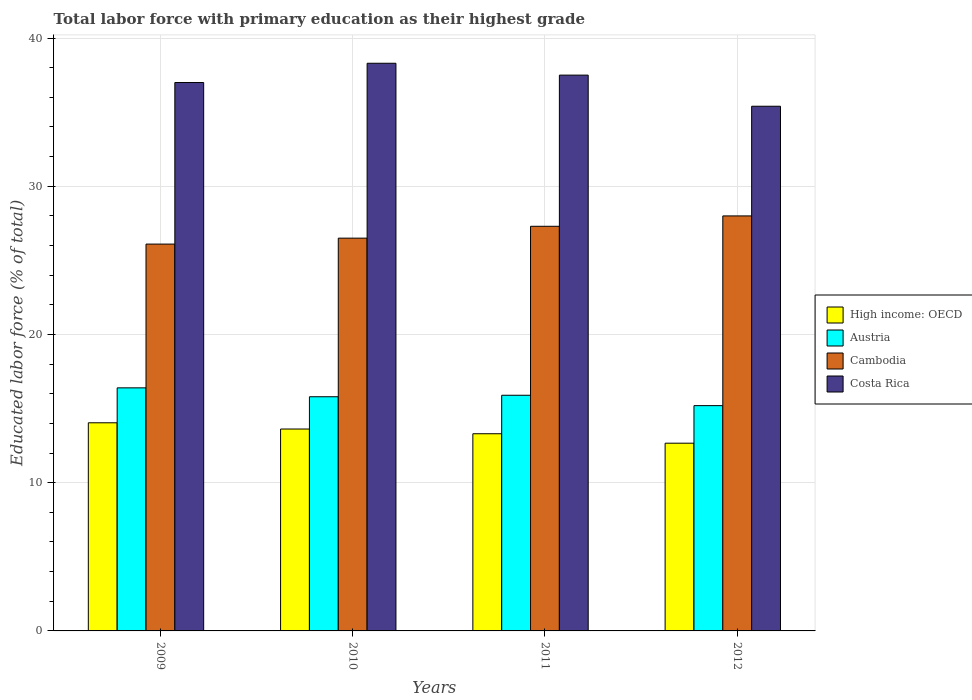Are the number of bars per tick equal to the number of legend labels?
Keep it short and to the point. Yes. Are the number of bars on each tick of the X-axis equal?
Ensure brevity in your answer.  Yes. What is the label of the 4th group of bars from the left?
Give a very brief answer. 2012. What is the percentage of total labor force with primary education in High income: OECD in 2009?
Your answer should be very brief. 14.04. Across all years, what is the maximum percentage of total labor force with primary education in Costa Rica?
Keep it short and to the point. 38.3. Across all years, what is the minimum percentage of total labor force with primary education in Costa Rica?
Ensure brevity in your answer.  35.4. In which year was the percentage of total labor force with primary education in High income: OECD minimum?
Provide a succinct answer. 2012. What is the total percentage of total labor force with primary education in Costa Rica in the graph?
Give a very brief answer. 148.2. What is the difference between the percentage of total labor force with primary education in Costa Rica in 2009 and that in 2012?
Your answer should be very brief. 1.6. What is the average percentage of total labor force with primary education in Costa Rica per year?
Your answer should be compact. 37.05. In the year 2009, what is the difference between the percentage of total labor force with primary education in Austria and percentage of total labor force with primary education in Cambodia?
Keep it short and to the point. -9.7. What is the ratio of the percentage of total labor force with primary education in Austria in 2009 to that in 2011?
Provide a succinct answer. 1.03. Is the percentage of total labor force with primary education in Cambodia in 2010 less than that in 2011?
Give a very brief answer. Yes. What is the difference between the highest and the second highest percentage of total labor force with primary education in Cambodia?
Offer a terse response. 0.7. What is the difference between the highest and the lowest percentage of total labor force with primary education in Austria?
Your response must be concise. 1.2. In how many years, is the percentage of total labor force with primary education in High income: OECD greater than the average percentage of total labor force with primary education in High income: OECD taken over all years?
Offer a very short reply. 2. Is it the case that in every year, the sum of the percentage of total labor force with primary education in High income: OECD and percentage of total labor force with primary education in Austria is greater than the sum of percentage of total labor force with primary education in Cambodia and percentage of total labor force with primary education in Costa Rica?
Your response must be concise. No. What does the 2nd bar from the left in 2009 represents?
Offer a terse response. Austria. What does the 1st bar from the right in 2011 represents?
Your answer should be very brief. Costa Rica. Is it the case that in every year, the sum of the percentage of total labor force with primary education in Cambodia and percentage of total labor force with primary education in Austria is greater than the percentage of total labor force with primary education in High income: OECD?
Give a very brief answer. Yes. How many years are there in the graph?
Offer a terse response. 4. Are the values on the major ticks of Y-axis written in scientific E-notation?
Keep it short and to the point. No. Does the graph contain grids?
Keep it short and to the point. Yes. Where does the legend appear in the graph?
Your answer should be very brief. Center right. How are the legend labels stacked?
Offer a terse response. Vertical. What is the title of the graph?
Make the answer very short. Total labor force with primary education as their highest grade. What is the label or title of the Y-axis?
Ensure brevity in your answer.  Educated labor force (% of total). What is the Educated labor force (% of total) of High income: OECD in 2009?
Your response must be concise. 14.04. What is the Educated labor force (% of total) in Austria in 2009?
Your response must be concise. 16.4. What is the Educated labor force (% of total) in Cambodia in 2009?
Provide a succinct answer. 26.1. What is the Educated labor force (% of total) in Costa Rica in 2009?
Make the answer very short. 37. What is the Educated labor force (% of total) of High income: OECD in 2010?
Your answer should be very brief. 13.62. What is the Educated labor force (% of total) in Austria in 2010?
Offer a terse response. 15.8. What is the Educated labor force (% of total) in Costa Rica in 2010?
Your answer should be very brief. 38.3. What is the Educated labor force (% of total) in High income: OECD in 2011?
Offer a terse response. 13.3. What is the Educated labor force (% of total) in Austria in 2011?
Provide a short and direct response. 15.9. What is the Educated labor force (% of total) in Cambodia in 2011?
Keep it short and to the point. 27.3. What is the Educated labor force (% of total) of Costa Rica in 2011?
Offer a terse response. 37.5. What is the Educated labor force (% of total) of High income: OECD in 2012?
Offer a terse response. 12.67. What is the Educated labor force (% of total) in Austria in 2012?
Your response must be concise. 15.2. What is the Educated labor force (% of total) of Costa Rica in 2012?
Ensure brevity in your answer.  35.4. Across all years, what is the maximum Educated labor force (% of total) in High income: OECD?
Your answer should be compact. 14.04. Across all years, what is the maximum Educated labor force (% of total) of Austria?
Ensure brevity in your answer.  16.4. Across all years, what is the maximum Educated labor force (% of total) of Costa Rica?
Your answer should be compact. 38.3. Across all years, what is the minimum Educated labor force (% of total) of High income: OECD?
Give a very brief answer. 12.67. Across all years, what is the minimum Educated labor force (% of total) in Austria?
Your answer should be compact. 15.2. Across all years, what is the minimum Educated labor force (% of total) of Cambodia?
Keep it short and to the point. 26.1. Across all years, what is the minimum Educated labor force (% of total) of Costa Rica?
Offer a very short reply. 35.4. What is the total Educated labor force (% of total) in High income: OECD in the graph?
Give a very brief answer. 53.64. What is the total Educated labor force (% of total) in Austria in the graph?
Your answer should be compact. 63.3. What is the total Educated labor force (% of total) of Cambodia in the graph?
Your answer should be very brief. 107.9. What is the total Educated labor force (% of total) in Costa Rica in the graph?
Ensure brevity in your answer.  148.2. What is the difference between the Educated labor force (% of total) in High income: OECD in 2009 and that in 2010?
Provide a succinct answer. 0.42. What is the difference between the Educated labor force (% of total) of Austria in 2009 and that in 2010?
Your answer should be compact. 0.6. What is the difference between the Educated labor force (% of total) in High income: OECD in 2009 and that in 2011?
Provide a short and direct response. 0.74. What is the difference between the Educated labor force (% of total) in Costa Rica in 2009 and that in 2011?
Provide a succinct answer. -0.5. What is the difference between the Educated labor force (% of total) in High income: OECD in 2009 and that in 2012?
Provide a short and direct response. 1.38. What is the difference between the Educated labor force (% of total) of Austria in 2009 and that in 2012?
Your answer should be compact. 1.2. What is the difference between the Educated labor force (% of total) of Cambodia in 2009 and that in 2012?
Provide a succinct answer. -1.9. What is the difference between the Educated labor force (% of total) in Costa Rica in 2009 and that in 2012?
Ensure brevity in your answer.  1.6. What is the difference between the Educated labor force (% of total) in High income: OECD in 2010 and that in 2011?
Keep it short and to the point. 0.32. What is the difference between the Educated labor force (% of total) of Cambodia in 2010 and that in 2011?
Give a very brief answer. -0.8. What is the difference between the Educated labor force (% of total) of High income: OECD in 2010 and that in 2012?
Ensure brevity in your answer.  0.96. What is the difference between the Educated labor force (% of total) in Costa Rica in 2010 and that in 2012?
Your answer should be compact. 2.9. What is the difference between the Educated labor force (% of total) in High income: OECD in 2011 and that in 2012?
Provide a succinct answer. 0.64. What is the difference between the Educated labor force (% of total) in Costa Rica in 2011 and that in 2012?
Provide a short and direct response. 2.1. What is the difference between the Educated labor force (% of total) in High income: OECD in 2009 and the Educated labor force (% of total) in Austria in 2010?
Your response must be concise. -1.76. What is the difference between the Educated labor force (% of total) in High income: OECD in 2009 and the Educated labor force (% of total) in Cambodia in 2010?
Your answer should be compact. -12.46. What is the difference between the Educated labor force (% of total) in High income: OECD in 2009 and the Educated labor force (% of total) in Costa Rica in 2010?
Provide a short and direct response. -24.26. What is the difference between the Educated labor force (% of total) of Austria in 2009 and the Educated labor force (% of total) of Cambodia in 2010?
Make the answer very short. -10.1. What is the difference between the Educated labor force (% of total) of Austria in 2009 and the Educated labor force (% of total) of Costa Rica in 2010?
Your answer should be compact. -21.9. What is the difference between the Educated labor force (% of total) in High income: OECD in 2009 and the Educated labor force (% of total) in Austria in 2011?
Ensure brevity in your answer.  -1.86. What is the difference between the Educated labor force (% of total) of High income: OECD in 2009 and the Educated labor force (% of total) of Cambodia in 2011?
Provide a short and direct response. -13.26. What is the difference between the Educated labor force (% of total) in High income: OECD in 2009 and the Educated labor force (% of total) in Costa Rica in 2011?
Give a very brief answer. -23.46. What is the difference between the Educated labor force (% of total) in Austria in 2009 and the Educated labor force (% of total) in Costa Rica in 2011?
Provide a short and direct response. -21.1. What is the difference between the Educated labor force (% of total) in High income: OECD in 2009 and the Educated labor force (% of total) in Austria in 2012?
Your answer should be compact. -1.16. What is the difference between the Educated labor force (% of total) in High income: OECD in 2009 and the Educated labor force (% of total) in Cambodia in 2012?
Your answer should be very brief. -13.96. What is the difference between the Educated labor force (% of total) of High income: OECD in 2009 and the Educated labor force (% of total) of Costa Rica in 2012?
Ensure brevity in your answer.  -21.36. What is the difference between the Educated labor force (% of total) in Austria in 2009 and the Educated labor force (% of total) in Cambodia in 2012?
Provide a succinct answer. -11.6. What is the difference between the Educated labor force (% of total) in High income: OECD in 2010 and the Educated labor force (% of total) in Austria in 2011?
Make the answer very short. -2.28. What is the difference between the Educated labor force (% of total) in High income: OECD in 2010 and the Educated labor force (% of total) in Cambodia in 2011?
Give a very brief answer. -13.68. What is the difference between the Educated labor force (% of total) in High income: OECD in 2010 and the Educated labor force (% of total) in Costa Rica in 2011?
Provide a short and direct response. -23.88. What is the difference between the Educated labor force (% of total) of Austria in 2010 and the Educated labor force (% of total) of Costa Rica in 2011?
Offer a very short reply. -21.7. What is the difference between the Educated labor force (% of total) of Cambodia in 2010 and the Educated labor force (% of total) of Costa Rica in 2011?
Keep it short and to the point. -11. What is the difference between the Educated labor force (% of total) of High income: OECD in 2010 and the Educated labor force (% of total) of Austria in 2012?
Provide a short and direct response. -1.58. What is the difference between the Educated labor force (% of total) of High income: OECD in 2010 and the Educated labor force (% of total) of Cambodia in 2012?
Your response must be concise. -14.38. What is the difference between the Educated labor force (% of total) in High income: OECD in 2010 and the Educated labor force (% of total) in Costa Rica in 2012?
Provide a succinct answer. -21.78. What is the difference between the Educated labor force (% of total) of Austria in 2010 and the Educated labor force (% of total) of Costa Rica in 2012?
Ensure brevity in your answer.  -19.6. What is the difference between the Educated labor force (% of total) in High income: OECD in 2011 and the Educated labor force (% of total) in Austria in 2012?
Your response must be concise. -1.9. What is the difference between the Educated labor force (% of total) in High income: OECD in 2011 and the Educated labor force (% of total) in Cambodia in 2012?
Offer a very short reply. -14.7. What is the difference between the Educated labor force (% of total) of High income: OECD in 2011 and the Educated labor force (% of total) of Costa Rica in 2012?
Your answer should be compact. -22.1. What is the difference between the Educated labor force (% of total) in Austria in 2011 and the Educated labor force (% of total) in Cambodia in 2012?
Offer a terse response. -12.1. What is the difference between the Educated labor force (% of total) of Austria in 2011 and the Educated labor force (% of total) of Costa Rica in 2012?
Give a very brief answer. -19.5. What is the average Educated labor force (% of total) of High income: OECD per year?
Keep it short and to the point. 13.41. What is the average Educated labor force (% of total) in Austria per year?
Keep it short and to the point. 15.82. What is the average Educated labor force (% of total) of Cambodia per year?
Ensure brevity in your answer.  26.98. What is the average Educated labor force (% of total) of Costa Rica per year?
Your answer should be very brief. 37.05. In the year 2009, what is the difference between the Educated labor force (% of total) of High income: OECD and Educated labor force (% of total) of Austria?
Provide a short and direct response. -2.36. In the year 2009, what is the difference between the Educated labor force (% of total) of High income: OECD and Educated labor force (% of total) of Cambodia?
Offer a very short reply. -12.06. In the year 2009, what is the difference between the Educated labor force (% of total) of High income: OECD and Educated labor force (% of total) of Costa Rica?
Offer a terse response. -22.96. In the year 2009, what is the difference between the Educated labor force (% of total) of Austria and Educated labor force (% of total) of Costa Rica?
Your answer should be very brief. -20.6. In the year 2010, what is the difference between the Educated labor force (% of total) in High income: OECD and Educated labor force (% of total) in Austria?
Ensure brevity in your answer.  -2.18. In the year 2010, what is the difference between the Educated labor force (% of total) in High income: OECD and Educated labor force (% of total) in Cambodia?
Provide a succinct answer. -12.88. In the year 2010, what is the difference between the Educated labor force (% of total) in High income: OECD and Educated labor force (% of total) in Costa Rica?
Keep it short and to the point. -24.68. In the year 2010, what is the difference between the Educated labor force (% of total) of Austria and Educated labor force (% of total) of Costa Rica?
Keep it short and to the point. -22.5. In the year 2010, what is the difference between the Educated labor force (% of total) in Cambodia and Educated labor force (% of total) in Costa Rica?
Offer a terse response. -11.8. In the year 2011, what is the difference between the Educated labor force (% of total) in High income: OECD and Educated labor force (% of total) in Austria?
Keep it short and to the point. -2.6. In the year 2011, what is the difference between the Educated labor force (% of total) of High income: OECD and Educated labor force (% of total) of Cambodia?
Your response must be concise. -14. In the year 2011, what is the difference between the Educated labor force (% of total) of High income: OECD and Educated labor force (% of total) of Costa Rica?
Provide a short and direct response. -24.2. In the year 2011, what is the difference between the Educated labor force (% of total) of Austria and Educated labor force (% of total) of Cambodia?
Make the answer very short. -11.4. In the year 2011, what is the difference between the Educated labor force (% of total) of Austria and Educated labor force (% of total) of Costa Rica?
Make the answer very short. -21.6. In the year 2012, what is the difference between the Educated labor force (% of total) in High income: OECD and Educated labor force (% of total) in Austria?
Provide a short and direct response. -2.53. In the year 2012, what is the difference between the Educated labor force (% of total) of High income: OECD and Educated labor force (% of total) of Cambodia?
Keep it short and to the point. -15.33. In the year 2012, what is the difference between the Educated labor force (% of total) of High income: OECD and Educated labor force (% of total) of Costa Rica?
Provide a short and direct response. -22.73. In the year 2012, what is the difference between the Educated labor force (% of total) in Austria and Educated labor force (% of total) in Costa Rica?
Your answer should be compact. -20.2. In the year 2012, what is the difference between the Educated labor force (% of total) in Cambodia and Educated labor force (% of total) in Costa Rica?
Offer a terse response. -7.4. What is the ratio of the Educated labor force (% of total) in High income: OECD in 2009 to that in 2010?
Make the answer very short. 1.03. What is the ratio of the Educated labor force (% of total) in Austria in 2009 to that in 2010?
Your answer should be compact. 1.04. What is the ratio of the Educated labor force (% of total) in Cambodia in 2009 to that in 2010?
Ensure brevity in your answer.  0.98. What is the ratio of the Educated labor force (% of total) in Costa Rica in 2009 to that in 2010?
Offer a very short reply. 0.97. What is the ratio of the Educated labor force (% of total) in High income: OECD in 2009 to that in 2011?
Your response must be concise. 1.06. What is the ratio of the Educated labor force (% of total) in Austria in 2009 to that in 2011?
Give a very brief answer. 1.03. What is the ratio of the Educated labor force (% of total) in Cambodia in 2009 to that in 2011?
Ensure brevity in your answer.  0.96. What is the ratio of the Educated labor force (% of total) in Costa Rica in 2009 to that in 2011?
Your answer should be compact. 0.99. What is the ratio of the Educated labor force (% of total) of High income: OECD in 2009 to that in 2012?
Provide a succinct answer. 1.11. What is the ratio of the Educated labor force (% of total) in Austria in 2009 to that in 2012?
Ensure brevity in your answer.  1.08. What is the ratio of the Educated labor force (% of total) of Cambodia in 2009 to that in 2012?
Your response must be concise. 0.93. What is the ratio of the Educated labor force (% of total) in Costa Rica in 2009 to that in 2012?
Your response must be concise. 1.05. What is the ratio of the Educated labor force (% of total) in High income: OECD in 2010 to that in 2011?
Make the answer very short. 1.02. What is the ratio of the Educated labor force (% of total) of Cambodia in 2010 to that in 2011?
Provide a short and direct response. 0.97. What is the ratio of the Educated labor force (% of total) in Costa Rica in 2010 to that in 2011?
Your answer should be compact. 1.02. What is the ratio of the Educated labor force (% of total) of High income: OECD in 2010 to that in 2012?
Offer a terse response. 1.08. What is the ratio of the Educated labor force (% of total) of Austria in 2010 to that in 2012?
Ensure brevity in your answer.  1.04. What is the ratio of the Educated labor force (% of total) in Cambodia in 2010 to that in 2012?
Provide a succinct answer. 0.95. What is the ratio of the Educated labor force (% of total) in Costa Rica in 2010 to that in 2012?
Offer a terse response. 1.08. What is the ratio of the Educated labor force (% of total) of High income: OECD in 2011 to that in 2012?
Ensure brevity in your answer.  1.05. What is the ratio of the Educated labor force (% of total) in Austria in 2011 to that in 2012?
Provide a short and direct response. 1.05. What is the ratio of the Educated labor force (% of total) in Costa Rica in 2011 to that in 2012?
Provide a succinct answer. 1.06. What is the difference between the highest and the second highest Educated labor force (% of total) of High income: OECD?
Offer a very short reply. 0.42. What is the difference between the highest and the second highest Educated labor force (% of total) in Cambodia?
Keep it short and to the point. 0.7. What is the difference between the highest and the lowest Educated labor force (% of total) in High income: OECD?
Offer a very short reply. 1.38. What is the difference between the highest and the lowest Educated labor force (% of total) in Costa Rica?
Your answer should be very brief. 2.9. 